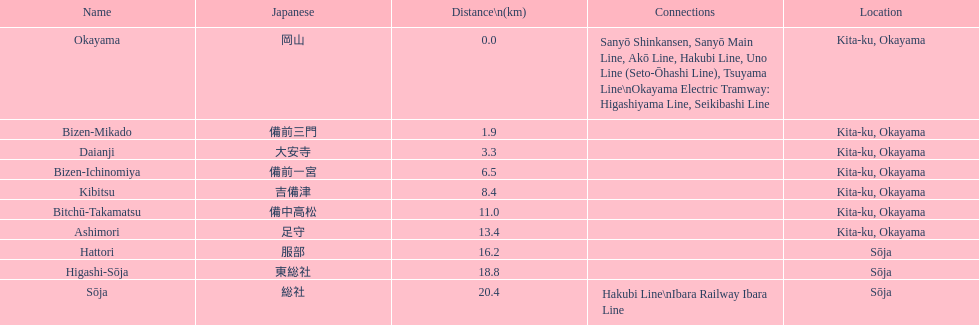Name only the stations that have connections to other lines. Okayama, Sōja. 